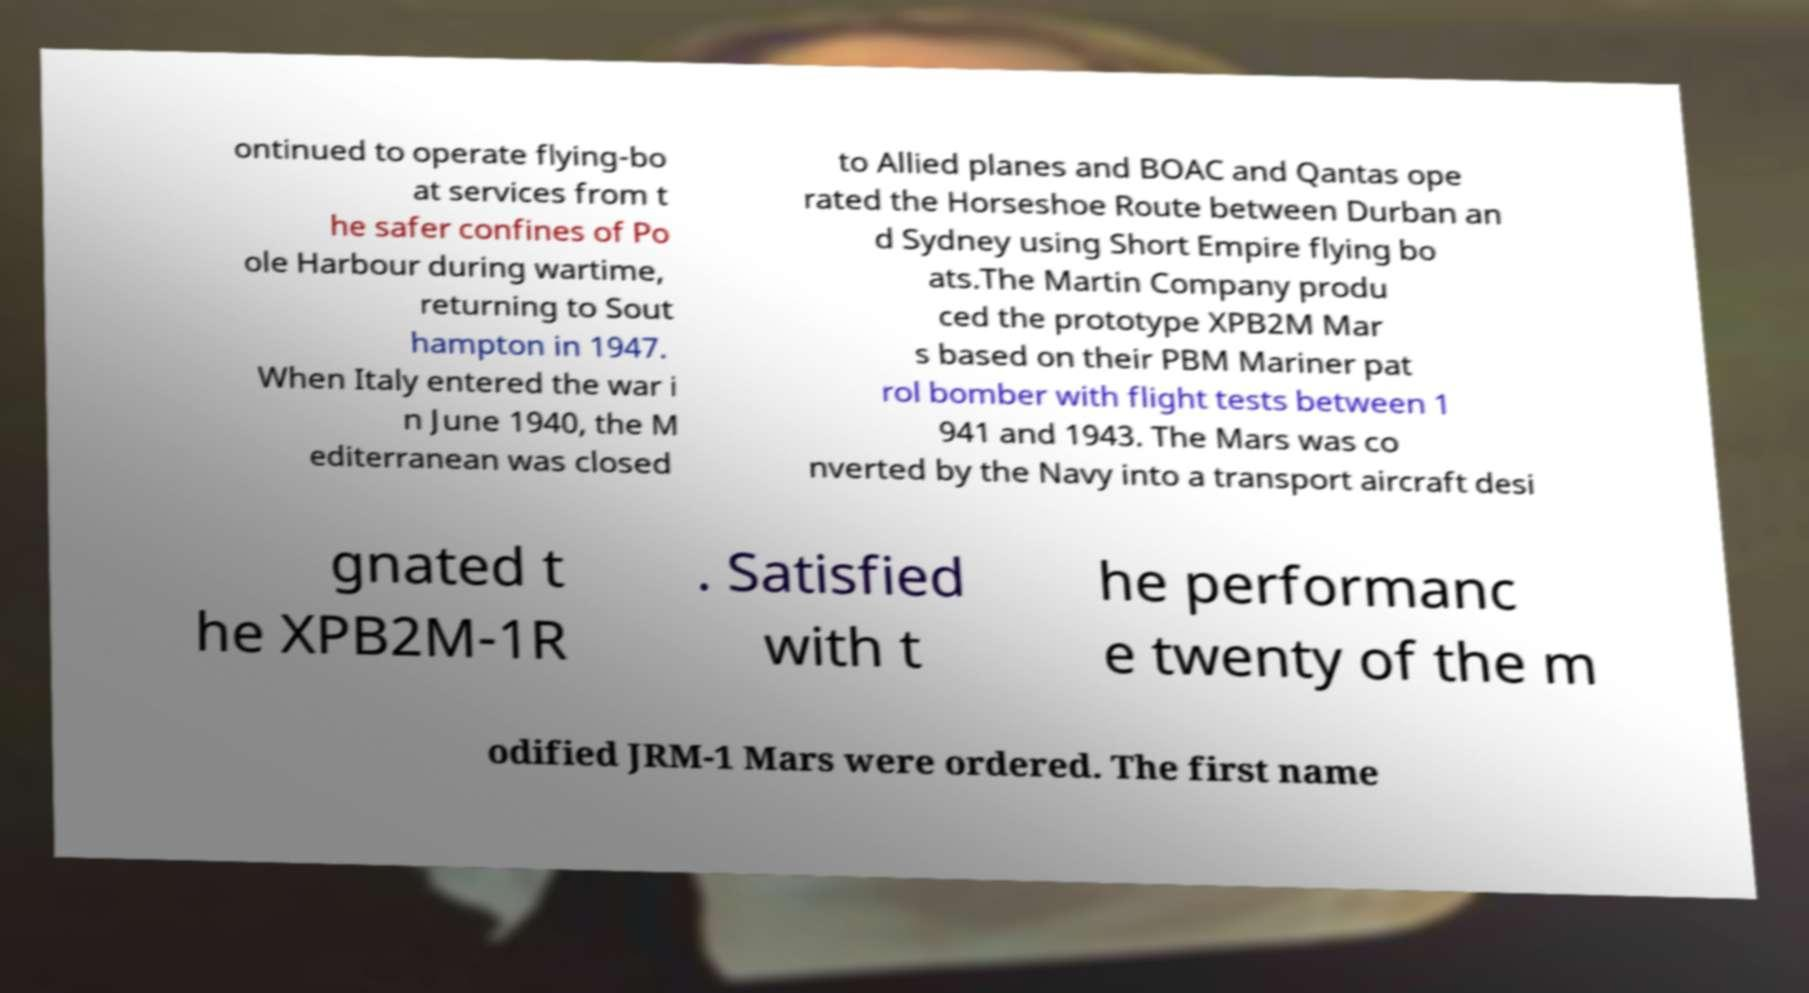For documentation purposes, I need the text within this image transcribed. Could you provide that? ontinued to operate flying-bo at services from t he safer confines of Po ole Harbour during wartime, returning to Sout hampton in 1947. When Italy entered the war i n June 1940, the M editerranean was closed to Allied planes and BOAC and Qantas ope rated the Horseshoe Route between Durban an d Sydney using Short Empire flying bo ats.The Martin Company produ ced the prototype XPB2M Mar s based on their PBM Mariner pat rol bomber with flight tests between 1 941 and 1943. The Mars was co nverted by the Navy into a transport aircraft desi gnated t he XPB2M-1R . Satisfied with t he performanc e twenty of the m odified JRM-1 Mars were ordered. The first name 